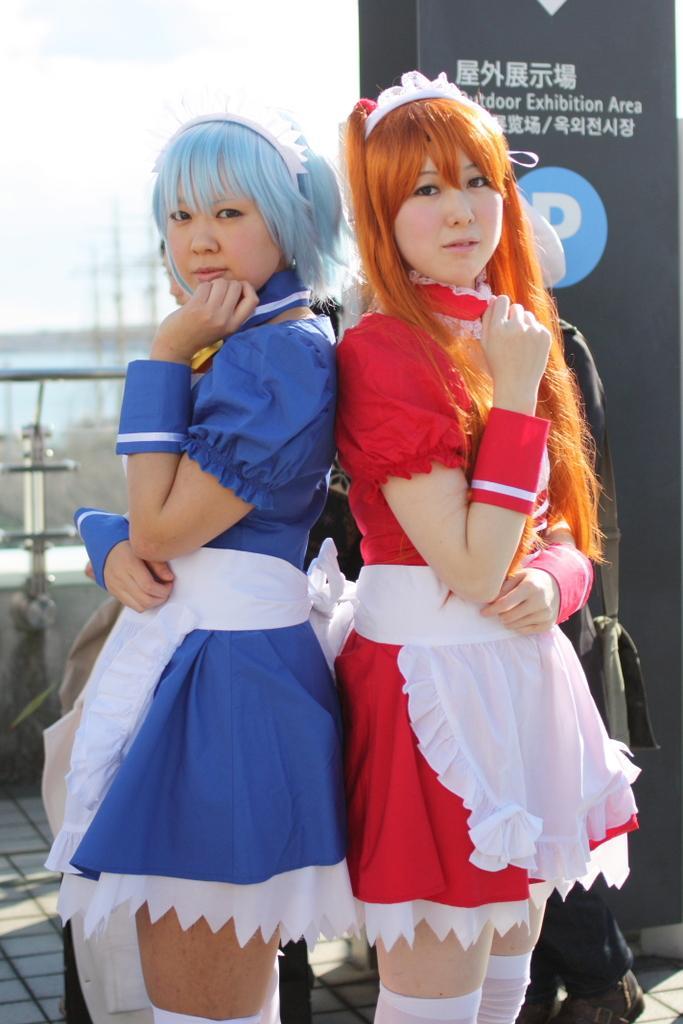In one or two sentences, can you explain what this image depicts? In this picture we can observe two women wearing blue and red color dresses. We can observe blue and brown color hair. In the background there is a railing and a sky. 